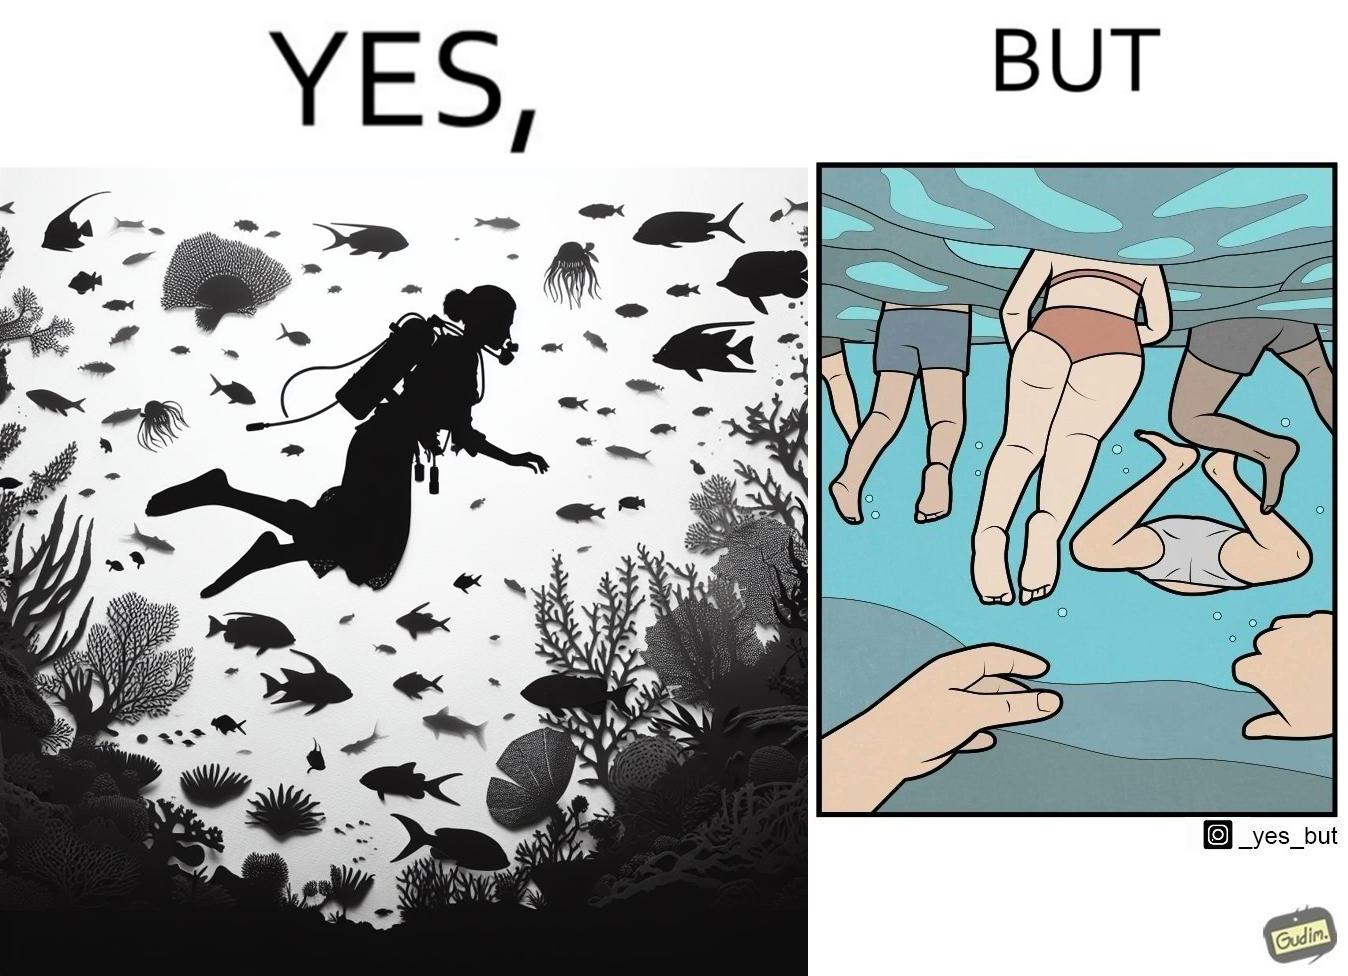Describe the content of this image. The image is ironic, because some people like to enjoy watching the biodiversity under water but they are not able to explore this due to excess crowd in such places where people like to play, swim etc. in water 